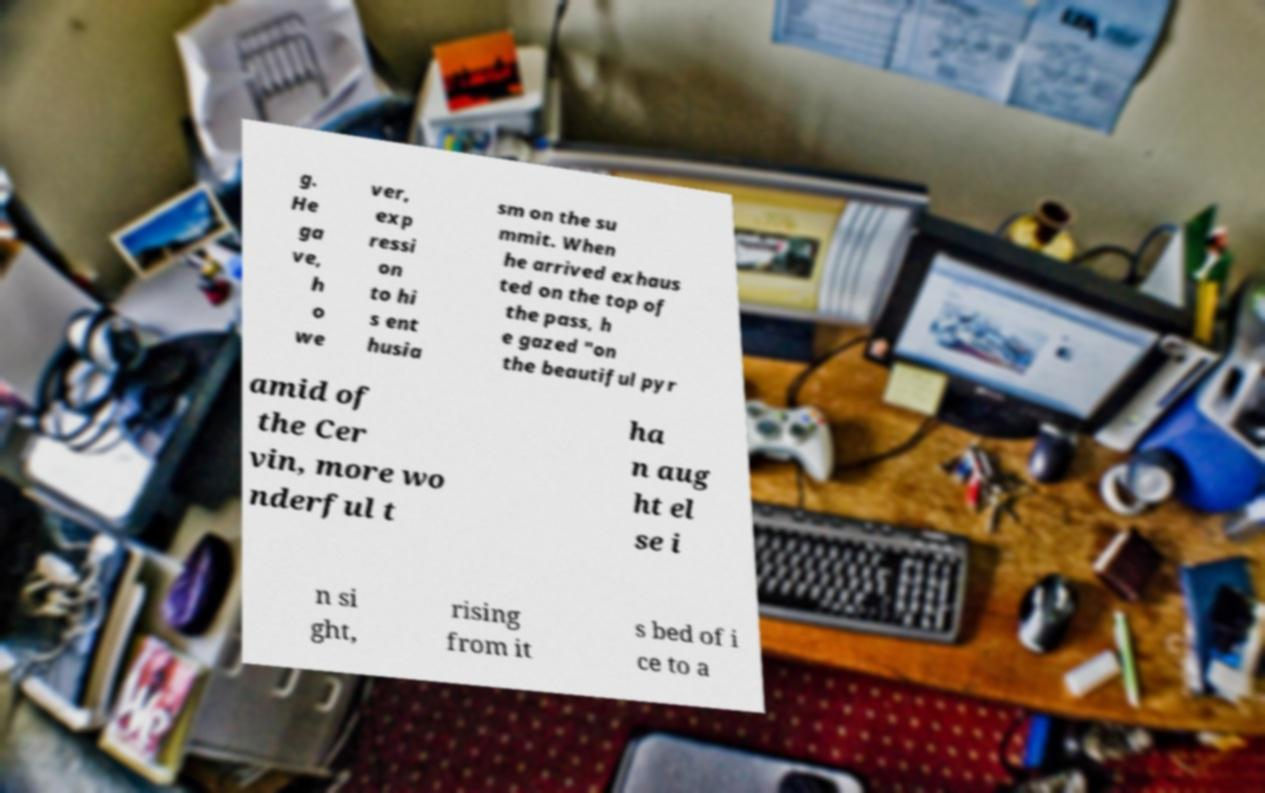Can you read and provide the text displayed in the image?This photo seems to have some interesting text. Can you extract and type it out for me? g. He ga ve, h o we ver, exp ressi on to hi s ent husia sm on the su mmit. When he arrived exhaus ted on the top of the pass, h e gazed "on the beautiful pyr amid of the Cer vin, more wo nderful t ha n aug ht el se i n si ght, rising from it s bed of i ce to a 